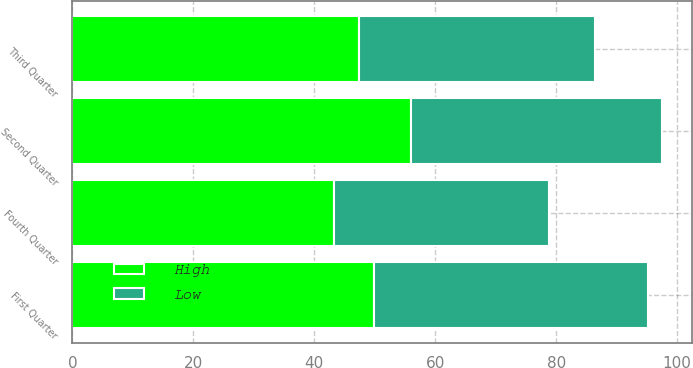Convert chart. <chart><loc_0><loc_0><loc_500><loc_500><stacked_bar_chart><ecel><fcel>First Quarter<fcel>Second Quarter<fcel>Third Quarter<fcel>Fourth Quarter<nl><fcel>High<fcel>49.91<fcel>56.06<fcel>47.45<fcel>43.29<nl><fcel>Low<fcel>45.22<fcel>41.5<fcel>38.93<fcel>35.5<nl></chart> 